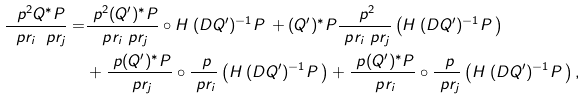Convert formula to latex. <formula><loc_0><loc_0><loc_500><loc_500>\frac { \ p ^ { 2 } Q ^ { * } \L P } { \ p r _ { i } \ p r _ { j } } = & \frac { \ p ^ { 2 } ( Q ^ { \prime } ) ^ { * } \L P } { \ p r _ { i } \ p r _ { j } } \circ H _ { \mathbf r } ( D Q ^ { \prime } ) ^ { - 1 } P _ { \mathbf r } + ( Q ^ { \prime } ) ^ { * } \L P \frac { \ p ^ { 2 } } { \ p r _ { i } \ p r _ { j } } \left ( H _ { \mathbf r } ( D Q ^ { \prime } ) ^ { - 1 } P _ { \mathbf r } \right ) \\ & + \frac { \ p ( Q ^ { \prime } ) ^ { * } \L P } { \ p r _ { j } } \circ \frac { \ p } { \ p r _ { i } } \left ( H _ { \mathbf r } ( D Q ^ { \prime } ) ^ { - 1 } P _ { \mathbf r } \right ) + \frac { \ p ( Q ^ { \prime } ) ^ { * } \L P } { \ p r _ { i } } \circ \frac { \ p } { \ p r _ { j } } \left ( H _ { \mathbf r } ( D Q ^ { \prime } ) ^ { - 1 } P _ { \mathbf r } \right ) ,</formula> 